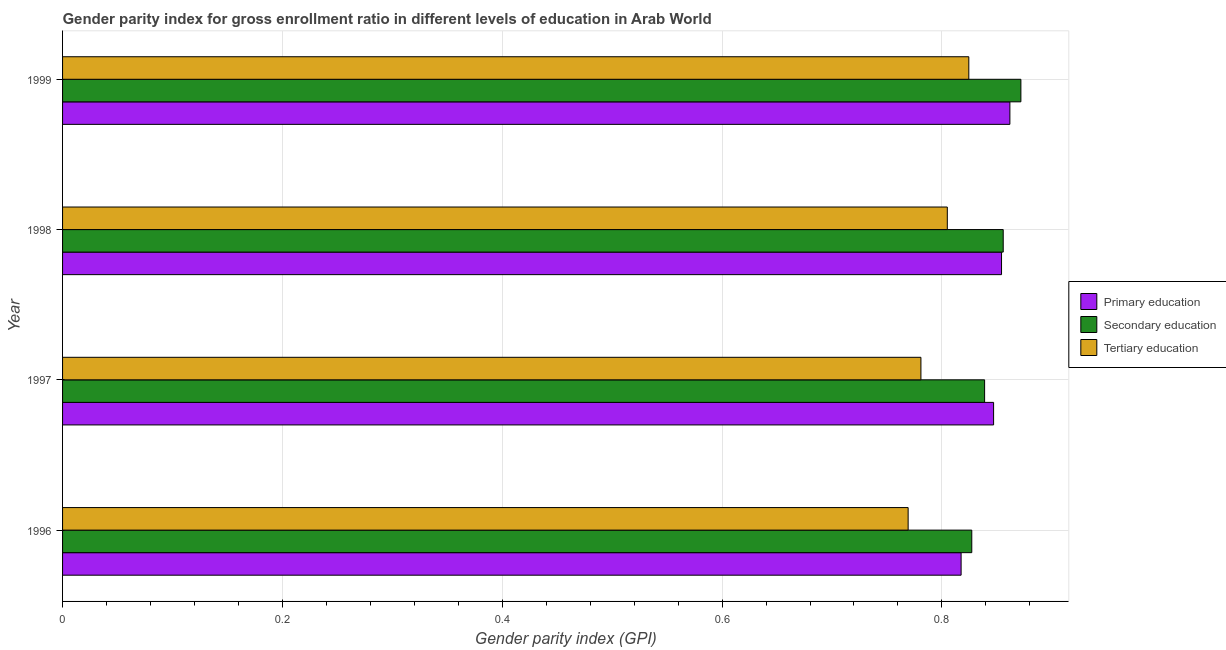How many different coloured bars are there?
Give a very brief answer. 3. How many groups of bars are there?
Give a very brief answer. 4. Are the number of bars per tick equal to the number of legend labels?
Offer a very short reply. Yes. How many bars are there on the 2nd tick from the bottom?
Offer a terse response. 3. What is the gender parity index in tertiary education in 1999?
Offer a terse response. 0.82. Across all years, what is the maximum gender parity index in tertiary education?
Your answer should be very brief. 0.82. Across all years, what is the minimum gender parity index in secondary education?
Give a very brief answer. 0.83. In which year was the gender parity index in secondary education maximum?
Your answer should be very brief. 1999. What is the total gender parity index in tertiary education in the graph?
Provide a short and direct response. 3.18. What is the difference between the gender parity index in primary education in 1996 and that in 1999?
Ensure brevity in your answer.  -0.04. What is the difference between the gender parity index in secondary education in 1999 and the gender parity index in primary education in 1997?
Offer a terse response. 0.02. What is the average gender parity index in primary education per year?
Offer a terse response. 0.84. In the year 1999, what is the difference between the gender parity index in tertiary education and gender parity index in secondary education?
Keep it short and to the point. -0.05. In how many years, is the gender parity index in tertiary education greater than 0.28 ?
Make the answer very short. 4. What is the ratio of the gender parity index in secondary education in 1998 to that in 1999?
Provide a short and direct response. 0.98. Is the gender parity index in primary education in 1998 less than that in 1999?
Provide a succinct answer. Yes. Is the difference between the gender parity index in primary education in 1997 and 1999 greater than the difference between the gender parity index in tertiary education in 1997 and 1999?
Offer a very short reply. Yes. What is the difference between the highest and the lowest gender parity index in tertiary education?
Make the answer very short. 0.06. In how many years, is the gender parity index in primary education greater than the average gender parity index in primary education taken over all years?
Your response must be concise. 3. Is the sum of the gender parity index in tertiary education in 1996 and 1998 greater than the maximum gender parity index in secondary education across all years?
Keep it short and to the point. Yes. What does the 1st bar from the top in 1998 represents?
Your response must be concise. Tertiary education. How many bars are there?
Provide a short and direct response. 12. Are all the bars in the graph horizontal?
Keep it short and to the point. Yes. What is the difference between two consecutive major ticks on the X-axis?
Your answer should be very brief. 0.2. Are the values on the major ticks of X-axis written in scientific E-notation?
Provide a succinct answer. No. Does the graph contain any zero values?
Give a very brief answer. No. Does the graph contain grids?
Ensure brevity in your answer.  Yes. Where does the legend appear in the graph?
Offer a very short reply. Center right. How are the legend labels stacked?
Provide a succinct answer. Vertical. What is the title of the graph?
Offer a very short reply. Gender parity index for gross enrollment ratio in different levels of education in Arab World. Does "Wage workers" appear as one of the legend labels in the graph?
Make the answer very short. No. What is the label or title of the X-axis?
Ensure brevity in your answer.  Gender parity index (GPI). What is the label or title of the Y-axis?
Offer a terse response. Year. What is the Gender parity index (GPI) of Primary education in 1996?
Provide a short and direct response. 0.82. What is the Gender parity index (GPI) in Secondary education in 1996?
Give a very brief answer. 0.83. What is the Gender parity index (GPI) of Tertiary education in 1996?
Your answer should be very brief. 0.77. What is the Gender parity index (GPI) of Primary education in 1997?
Your response must be concise. 0.85. What is the Gender parity index (GPI) of Secondary education in 1997?
Provide a succinct answer. 0.84. What is the Gender parity index (GPI) in Tertiary education in 1997?
Ensure brevity in your answer.  0.78. What is the Gender parity index (GPI) in Primary education in 1998?
Offer a terse response. 0.85. What is the Gender parity index (GPI) of Secondary education in 1998?
Provide a succinct answer. 0.86. What is the Gender parity index (GPI) in Tertiary education in 1998?
Provide a short and direct response. 0.8. What is the Gender parity index (GPI) in Primary education in 1999?
Provide a short and direct response. 0.86. What is the Gender parity index (GPI) of Secondary education in 1999?
Make the answer very short. 0.87. What is the Gender parity index (GPI) in Tertiary education in 1999?
Make the answer very short. 0.82. Across all years, what is the maximum Gender parity index (GPI) in Primary education?
Keep it short and to the point. 0.86. Across all years, what is the maximum Gender parity index (GPI) of Secondary education?
Give a very brief answer. 0.87. Across all years, what is the maximum Gender parity index (GPI) in Tertiary education?
Make the answer very short. 0.82. Across all years, what is the minimum Gender parity index (GPI) of Primary education?
Your answer should be very brief. 0.82. Across all years, what is the minimum Gender parity index (GPI) of Secondary education?
Offer a terse response. 0.83. Across all years, what is the minimum Gender parity index (GPI) of Tertiary education?
Your answer should be very brief. 0.77. What is the total Gender parity index (GPI) in Primary education in the graph?
Make the answer very short. 3.38. What is the total Gender parity index (GPI) of Secondary education in the graph?
Make the answer very short. 3.39. What is the total Gender parity index (GPI) in Tertiary education in the graph?
Offer a very short reply. 3.18. What is the difference between the Gender parity index (GPI) of Primary education in 1996 and that in 1997?
Your response must be concise. -0.03. What is the difference between the Gender parity index (GPI) in Secondary education in 1996 and that in 1997?
Provide a succinct answer. -0.01. What is the difference between the Gender parity index (GPI) in Tertiary education in 1996 and that in 1997?
Provide a short and direct response. -0.01. What is the difference between the Gender parity index (GPI) of Primary education in 1996 and that in 1998?
Your answer should be compact. -0.04. What is the difference between the Gender parity index (GPI) of Secondary education in 1996 and that in 1998?
Your answer should be compact. -0.03. What is the difference between the Gender parity index (GPI) in Tertiary education in 1996 and that in 1998?
Your response must be concise. -0.04. What is the difference between the Gender parity index (GPI) in Primary education in 1996 and that in 1999?
Provide a succinct answer. -0.04. What is the difference between the Gender parity index (GPI) in Secondary education in 1996 and that in 1999?
Provide a short and direct response. -0.04. What is the difference between the Gender parity index (GPI) in Tertiary education in 1996 and that in 1999?
Give a very brief answer. -0.06. What is the difference between the Gender parity index (GPI) in Primary education in 1997 and that in 1998?
Your response must be concise. -0.01. What is the difference between the Gender parity index (GPI) in Secondary education in 1997 and that in 1998?
Provide a succinct answer. -0.02. What is the difference between the Gender parity index (GPI) of Tertiary education in 1997 and that in 1998?
Provide a succinct answer. -0.02. What is the difference between the Gender parity index (GPI) of Primary education in 1997 and that in 1999?
Make the answer very short. -0.01. What is the difference between the Gender parity index (GPI) in Secondary education in 1997 and that in 1999?
Your answer should be compact. -0.03. What is the difference between the Gender parity index (GPI) in Tertiary education in 1997 and that in 1999?
Make the answer very short. -0.04. What is the difference between the Gender parity index (GPI) in Primary education in 1998 and that in 1999?
Give a very brief answer. -0.01. What is the difference between the Gender parity index (GPI) in Secondary education in 1998 and that in 1999?
Your answer should be very brief. -0.02. What is the difference between the Gender parity index (GPI) in Tertiary education in 1998 and that in 1999?
Provide a succinct answer. -0.02. What is the difference between the Gender parity index (GPI) in Primary education in 1996 and the Gender parity index (GPI) in Secondary education in 1997?
Provide a succinct answer. -0.02. What is the difference between the Gender parity index (GPI) in Primary education in 1996 and the Gender parity index (GPI) in Tertiary education in 1997?
Ensure brevity in your answer.  0.04. What is the difference between the Gender parity index (GPI) of Secondary education in 1996 and the Gender parity index (GPI) of Tertiary education in 1997?
Ensure brevity in your answer.  0.05. What is the difference between the Gender parity index (GPI) in Primary education in 1996 and the Gender parity index (GPI) in Secondary education in 1998?
Provide a short and direct response. -0.04. What is the difference between the Gender parity index (GPI) in Primary education in 1996 and the Gender parity index (GPI) in Tertiary education in 1998?
Make the answer very short. 0.01. What is the difference between the Gender parity index (GPI) of Secondary education in 1996 and the Gender parity index (GPI) of Tertiary education in 1998?
Your response must be concise. 0.02. What is the difference between the Gender parity index (GPI) in Primary education in 1996 and the Gender parity index (GPI) in Secondary education in 1999?
Make the answer very short. -0.05. What is the difference between the Gender parity index (GPI) in Primary education in 1996 and the Gender parity index (GPI) in Tertiary education in 1999?
Your response must be concise. -0.01. What is the difference between the Gender parity index (GPI) of Secondary education in 1996 and the Gender parity index (GPI) of Tertiary education in 1999?
Keep it short and to the point. 0. What is the difference between the Gender parity index (GPI) in Primary education in 1997 and the Gender parity index (GPI) in Secondary education in 1998?
Your answer should be very brief. -0.01. What is the difference between the Gender parity index (GPI) of Primary education in 1997 and the Gender parity index (GPI) of Tertiary education in 1998?
Provide a succinct answer. 0.04. What is the difference between the Gender parity index (GPI) in Secondary education in 1997 and the Gender parity index (GPI) in Tertiary education in 1998?
Offer a very short reply. 0.03. What is the difference between the Gender parity index (GPI) in Primary education in 1997 and the Gender parity index (GPI) in Secondary education in 1999?
Your answer should be compact. -0.02. What is the difference between the Gender parity index (GPI) in Primary education in 1997 and the Gender parity index (GPI) in Tertiary education in 1999?
Your answer should be very brief. 0.02. What is the difference between the Gender parity index (GPI) of Secondary education in 1997 and the Gender parity index (GPI) of Tertiary education in 1999?
Keep it short and to the point. 0.01. What is the difference between the Gender parity index (GPI) of Primary education in 1998 and the Gender parity index (GPI) of Secondary education in 1999?
Your answer should be compact. -0.02. What is the difference between the Gender parity index (GPI) of Primary education in 1998 and the Gender parity index (GPI) of Tertiary education in 1999?
Ensure brevity in your answer.  0.03. What is the difference between the Gender parity index (GPI) in Secondary education in 1998 and the Gender parity index (GPI) in Tertiary education in 1999?
Ensure brevity in your answer.  0.03. What is the average Gender parity index (GPI) of Primary education per year?
Offer a very short reply. 0.85. What is the average Gender parity index (GPI) in Secondary education per year?
Provide a short and direct response. 0.85. What is the average Gender parity index (GPI) of Tertiary education per year?
Provide a short and direct response. 0.79. In the year 1996, what is the difference between the Gender parity index (GPI) in Primary education and Gender parity index (GPI) in Secondary education?
Offer a terse response. -0.01. In the year 1996, what is the difference between the Gender parity index (GPI) of Primary education and Gender parity index (GPI) of Tertiary education?
Offer a terse response. 0.05. In the year 1996, what is the difference between the Gender parity index (GPI) of Secondary education and Gender parity index (GPI) of Tertiary education?
Offer a terse response. 0.06. In the year 1997, what is the difference between the Gender parity index (GPI) in Primary education and Gender parity index (GPI) in Secondary education?
Provide a short and direct response. 0.01. In the year 1997, what is the difference between the Gender parity index (GPI) in Primary education and Gender parity index (GPI) in Tertiary education?
Offer a very short reply. 0.07. In the year 1997, what is the difference between the Gender parity index (GPI) of Secondary education and Gender parity index (GPI) of Tertiary education?
Your answer should be compact. 0.06. In the year 1998, what is the difference between the Gender parity index (GPI) of Primary education and Gender parity index (GPI) of Secondary education?
Your answer should be compact. -0. In the year 1998, what is the difference between the Gender parity index (GPI) of Primary education and Gender parity index (GPI) of Tertiary education?
Offer a terse response. 0.05. In the year 1998, what is the difference between the Gender parity index (GPI) in Secondary education and Gender parity index (GPI) in Tertiary education?
Provide a short and direct response. 0.05. In the year 1999, what is the difference between the Gender parity index (GPI) in Primary education and Gender parity index (GPI) in Secondary education?
Give a very brief answer. -0.01. In the year 1999, what is the difference between the Gender parity index (GPI) of Primary education and Gender parity index (GPI) of Tertiary education?
Your response must be concise. 0.04. In the year 1999, what is the difference between the Gender parity index (GPI) in Secondary education and Gender parity index (GPI) in Tertiary education?
Provide a succinct answer. 0.05. What is the ratio of the Gender parity index (GPI) in Primary education in 1996 to that in 1997?
Provide a succinct answer. 0.97. What is the ratio of the Gender parity index (GPI) in Secondary education in 1996 to that in 1997?
Provide a succinct answer. 0.99. What is the ratio of the Gender parity index (GPI) of Tertiary education in 1996 to that in 1997?
Offer a terse response. 0.99. What is the ratio of the Gender parity index (GPI) of Primary education in 1996 to that in 1998?
Provide a short and direct response. 0.96. What is the ratio of the Gender parity index (GPI) in Secondary education in 1996 to that in 1998?
Your answer should be very brief. 0.97. What is the ratio of the Gender parity index (GPI) of Tertiary education in 1996 to that in 1998?
Ensure brevity in your answer.  0.96. What is the ratio of the Gender parity index (GPI) in Primary education in 1996 to that in 1999?
Give a very brief answer. 0.95. What is the ratio of the Gender parity index (GPI) in Secondary education in 1996 to that in 1999?
Your answer should be compact. 0.95. What is the ratio of the Gender parity index (GPI) of Tertiary education in 1996 to that in 1999?
Offer a terse response. 0.93. What is the ratio of the Gender parity index (GPI) of Secondary education in 1997 to that in 1998?
Your response must be concise. 0.98. What is the ratio of the Gender parity index (GPI) in Tertiary education in 1997 to that in 1998?
Provide a short and direct response. 0.97. What is the ratio of the Gender parity index (GPI) in Primary education in 1997 to that in 1999?
Provide a succinct answer. 0.98. What is the ratio of the Gender parity index (GPI) of Secondary education in 1997 to that in 1999?
Ensure brevity in your answer.  0.96. What is the ratio of the Gender parity index (GPI) of Tertiary education in 1997 to that in 1999?
Provide a short and direct response. 0.95. What is the ratio of the Gender parity index (GPI) in Secondary education in 1998 to that in 1999?
Offer a terse response. 0.98. What is the ratio of the Gender parity index (GPI) of Tertiary education in 1998 to that in 1999?
Offer a very short reply. 0.98. What is the difference between the highest and the second highest Gender parity index (GPI) of Primary education?
Offer a terse response. 0.01. What is the difference between the highest and the second highest Gender parity index (GPI) of Secondary education?
Provide a short and direct response. 0.02. What is the difference between the highest and the second highest Gender parity index (GPI) of Tertiary education?
Keep it short and to the point. 0.02. What is the difference between the highest and the lowest Gender parity index (GPI) in Primary education?
Give a very brief answer. 0.04. What is the difference between the highest and the lowest Gender parity index (GPI) in Secondary education?
Your answer should be compact. 0.04. What is the difference between the highest and the lowest Gender parity index (GPI) of Tertiary education?
Provide a succinct answer. 0.06. 